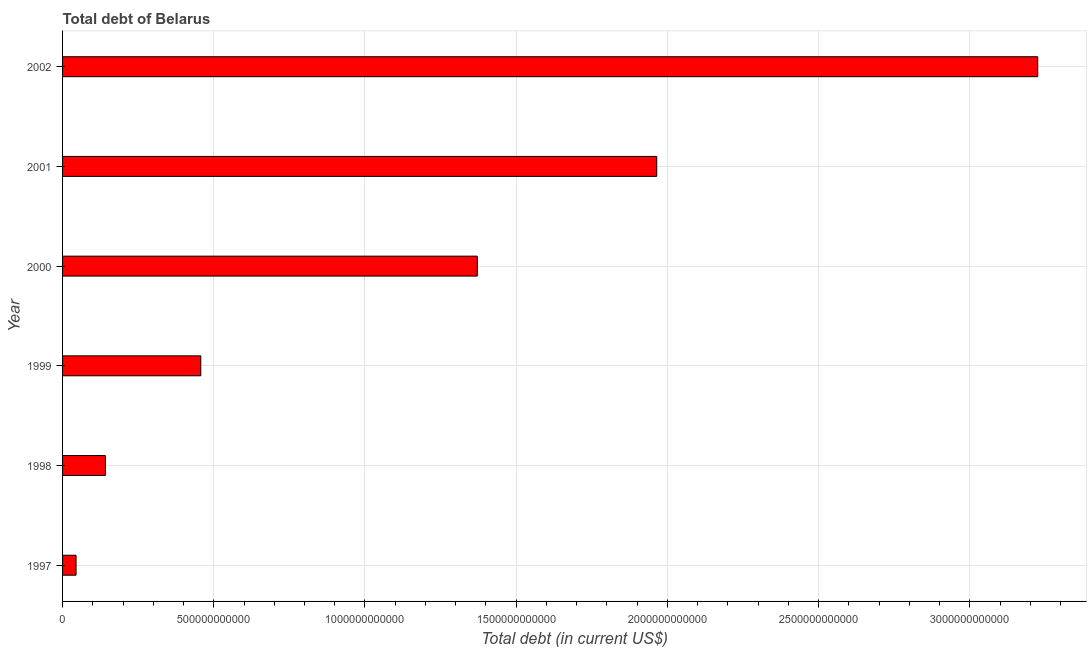Does the graph contain grids?
Provide a succinct answer. Yes. What is the title of the graph?
Offer a very short reply. Total debt of Belarus. What is the label or title of the X-axis?
Offer a terse response. Total debt (in current US$). What is the label or title of the Y-axis?
Your response must be concise. Year. What is the total debt in 2001?
Offer a very short reply. 1.96e+12. Across all years, what is the maximum total debt?
Give a very brief answer. 3.22e+12. Across all years, what is the minimum total debt?
Offer a very short reply. 4.46e+1. In which year was the total debt minimum?
Offer a terse response. 1997. What is the sum of the total debt?
Offer a terse response. 7.20e+12. What is the difference between the total debt in 2000 and 2002?
Make the answer very short. -1.85e+12. What is the average total debt per year?
Ensure brevity in your answer.  1.20e+12. What is the median total debt?
Offer a terse response. 9.14e+11. Do a majority of the years between 1999 and 2000 (inclusive) have total debt greater than 1500000000000 US$?
Make the answer very short. No. What is the ratio of the total debt in 1998 to that in 2000?
Provide a short and direct response. 0.1. Is the total debt in 2001 less than that in 2002?
Make the answer very short. Yes. Is the difference between the total debt in 1997 and 1998 greater than the difference between any two years?
Your answer should be compact. No. What is the difference between the highest and the second highest total debt?
Offer a very short reply. 1.26e+12. What is the difference between the highest and the lowest total debt?
Give a very brief answer. 3.18e+12. In how many years, is the total debt greater than the average total debt taken over all years?
Keep it short and to the point. 3. How many bars are there?
Ensure brevity in your answer.  6. How many years are there in the graph?
Make the answer very short. 6. What is the difference between two consecutive major ticks on the X-axis?
Offer a very short reply. 5.00e+11. What is the Total debt (in current US$) in 1997?
Keep it short and to the point. 4.46e+1. What is the Total debt (in current US$) of 1998?
Give a very brief answer. 1.42e+11. What is the Total debt (in current US$) in 1999?
Offer a terse response. 4.57e+11. What is the Total debt (in current US$) of 2000?
Ensure brevity in your answer.  1.37e+12. What is the Total debt (in current US$) of 2001?
Your response must be concise. 1.96e+12. What is the Total debt (in current US$) in 2002?
Provide a succinct answer. 3.22e+12. What is the difference between the Total debt (in current US$) in 1997 and 1998?
Give a very brief answer. -9.71e+1. What is the difference between the Total debt (in current US$) in 1997 and 1999?
Your answer should be compact. -4.12e+11. What is the difference between the Total debt (in current US$) in 1997 and 2000?
Offer a terse response. -1.33e+12. What is the difference between the Total debt (in current US$) in 1997 and 2001?
Keep it short and to the point. -1.92e+12. What is the difference between the Total debt (in current US$) in 1997 and 2002?
Your answer should be very brief. -3.18e+12. What is the difference between the Total debt (in current US$) in 1998 and 1999?
Provide a succinct answer. -3.15e+11. What is the difference between the Total debt (in current US$) in 1998 and 2000?
Offer a terse response. -1.23e+12. What is the difference between the Total debt (in current US$) in 1998 and 2001?
Offer a very short reply. -1.82e+12. What is the difference between the Total debt (in current US$) in 1998 and 2002?
Provide a short and direct response. -3.08e+12. What is the difference between the Total debt (in current US$) in 1999 and 2000?
Provide a short and direct response. -9.14e+11. What is the difference between the Total debt (in current US$) in 1999 and 2001?
Offer a terse response. -1.51e+12. What is the difference between the Total debt (in current US$) in 1999 and 2002?
Ensure brevity in your answer.  -2.77e+12. What is the difference between the Total debt (in current US$) in 2000 and 2001?
Your answer should be compact. -5.93e+11. What is the difference between the Total debt (in current US$) in 2000 and 2002?
Provide a succinct answer. -1.85e+12. What is the difference between the Total debt (in current US$) in 2001 and 2002?
Your answer should be compact. -1.26e+12. What is the ratio of the Total debt (in current US$) in 1997 to that in 1998?
Make the answer very short. 0.32. What is the ratio of the Total debt (in current US$) in 1997 to that in 1999?
Offer a very short reply. 0.1. What is the ratio of the Total debt (in current US$) in 1997 to that in 2000?
Give a very brief answer. 0.03. What is the ratio of the Total debt (in current US$) in 1997 to that in 2001?
Your answer should be very brief. 0.02. What is the ratio of the Total debt (in current US$) in 1997 to that in 2002?
Your answer should be very brief. 0.01. What is the ratio of the Total debt (in current US$) in 1998 to that in 1999?
Offer a terse response. 0.31. What is the ratio of the Total debt (in current US$) in 1998 to that in 2000?
Offer a very short reply. 0.1. What is the ratio of the Total debt (in current US$) in 1998 to that in 2001?
Your answer should be compact. 0.07. What is the ratio of the Total debt (in current US$) in 1998 to that in 2002?
Offer a very short reply. 0.04. What is the ratio of the Total debt (in current US$) in 1999 to that in 2000?
Provide a succinct answer. 0.33. What is the ratio of the Total debt (in current US$) in 1999 to that in 2001?
Offer a very short reply. 0.23. What is the ratio of the Total debt (in current US$) in 1999 to that in 2002?
Offer a very short reply. 0.14. What is the ratio of the Total debt (in current US$) in 2000 to that in 2001?
Keep it short and to the point. 0.7. What is the ratio of the Total debt (in current US$) in 2000 to that in 2002?
Offer a very short reply. 0.42. What is the ratio of the Total debt (in current US$) in 2001 to that in 2002?
Offer a terse response. 0.61. 